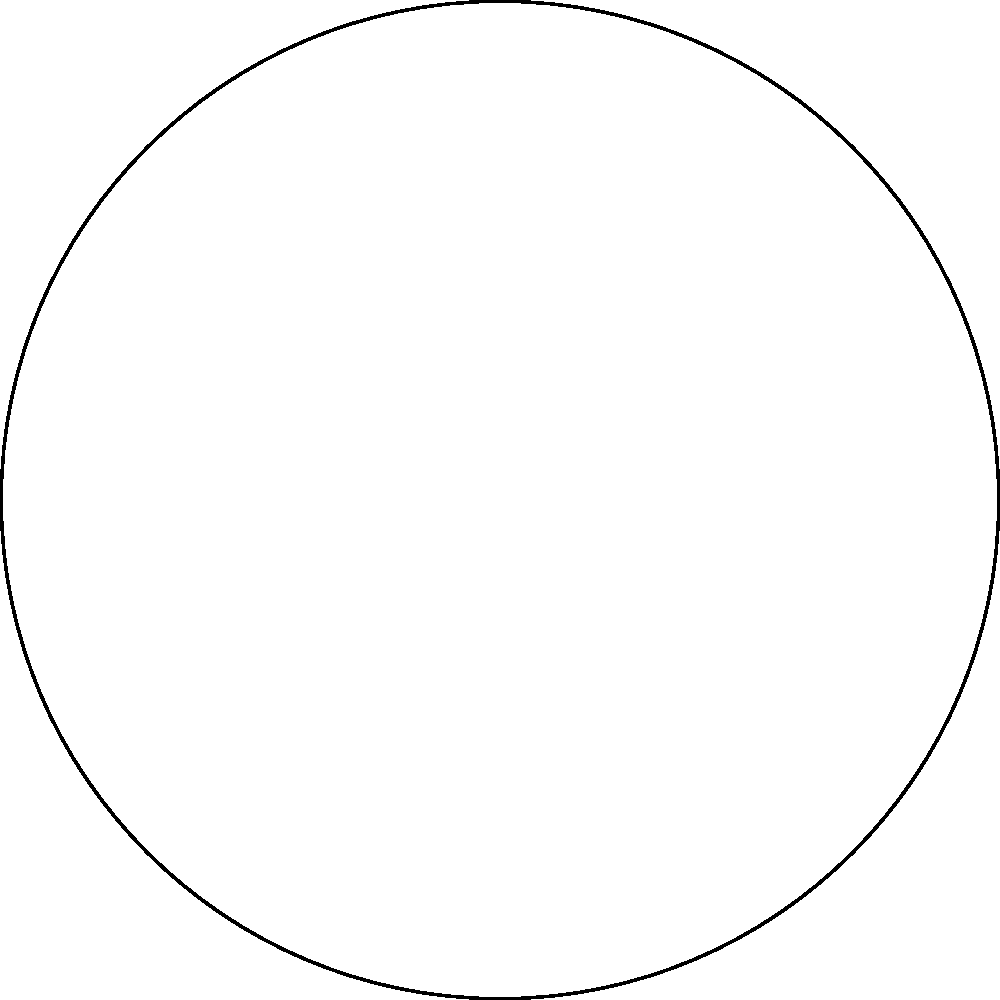In a Japanese woodblock print depicting stylized ocean waves, the artist has incorporated elements of elliptic geometry. Two "parallel" lines are represented by the blue and red arcs on the surface of a sphere, as shown in the diagram. If these lines are extended, how many points of intersection will they have? To understand this problem, we need to consider the properties of elliptic geometry:

1. In elliptic geometry, all lines are great circles on the surface of a sphere.

2. The concept of parallel lines in Euclidean geometry doesn't exist in elliptic geometry. Any two great circles will always intersect at two antipodal points.

3. In the given diagram, the blue arcs represent one "line" and the red arcs represent another "line" in elliptic geometry.

4. If we extend these arcs, they will form complete great circles on the sphere.

5. Great circles on a sphere always intersect at two points that are diametrically opposite to each other (antipodal points).

6. In this case, we can see that the blue and red arcs would intersect at points A and B if extended.

7. These points A and B are antipodal points on the sphere, representing the two points of intersection between the "parallel" lines in elliptic geometry.

Therefore, when extended, the two "parallel" lines represented by the blue and red arcs will intersect at two points.
Answer: 2 points 